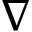<formula> <loc_0><loc_0><loc_500><loc_500>\nabla</formula> 